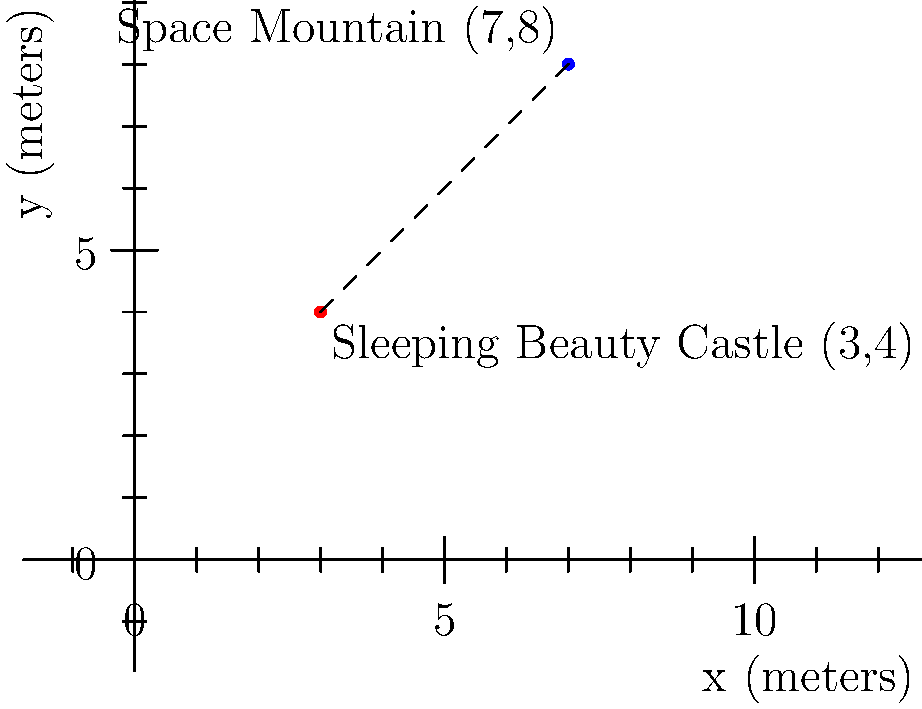As a travel blogger reviewing Disneyland, you want to calculate the distance between two iconic landmarks: Sleeping Beauty Castle and Space Mountain. Using the Cartesian coordinate system, where Sleeping Beauty Castle is located at (3,4) and Space Mountain is at (7,8), what is the straight-line distance between these two attractions in meters? To calculate the distance between two points in a Cartesian coordinate system, we can use the distance formula, which is derived from the Pythagorean theorem:

$$ d = \sqrt{(x_2 - x_1)^2 + (y_2 - y_1)^2} $$

Where $(x_1, y_1)$ is the coordinate of the first point and $(x_2, y_2)$ is the coordinate of the second point.

Let's plug in our values:
- Sleeping Beauty Castle: $(x_1, y_1) = (3, 4)$
- Space Mountain: $(x_2, y_2) = (7, 8)$

Now, let's calculate:

$$ d = \sqrt{(7 - 3)^2 + (8 - 4)^2} $$
$$ d = \sqrt{4^2 + 4^2} $$
$$ d = \sqrt{16 + 16} $$
$$ d = \sqrt{32} $$
$$ d = 4\sqrt{2} \approx 5.66 $$

Therefore, the straight-line distance between Sleeping Beauty Castle and Space Mountain is $4\sqrt{2}$ meters, or approximately 5.66 meters.
Answer: $4\sqrt{2}$ meters 